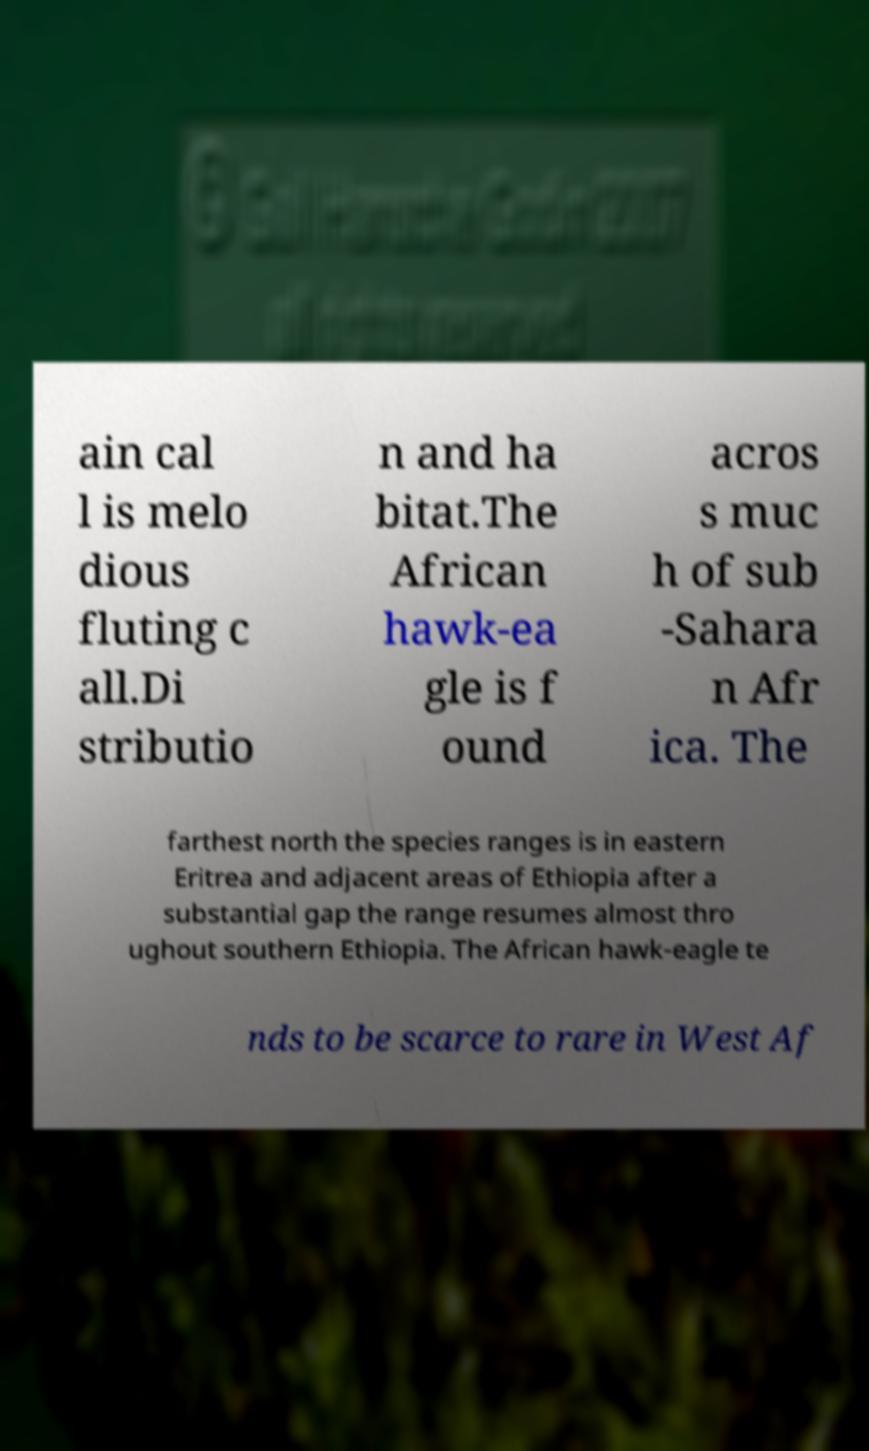There's text embedded in this image that I need extracted. Can you transcribe it verbatim? ain cal l is melo dious fluting c all.Di stributio n and ha bitat.The African hawk-ea gle is f ound acros s muc h of sub -Sahara n Afr ica. The farthest north the species ranges is in eastern Eritrea and adjacent areas of Ethiopia after a substantial gap the range resumes almost thro ughout southern Ethiopia. The African hawk-eagle te nds to be scarce to rare in West Af 